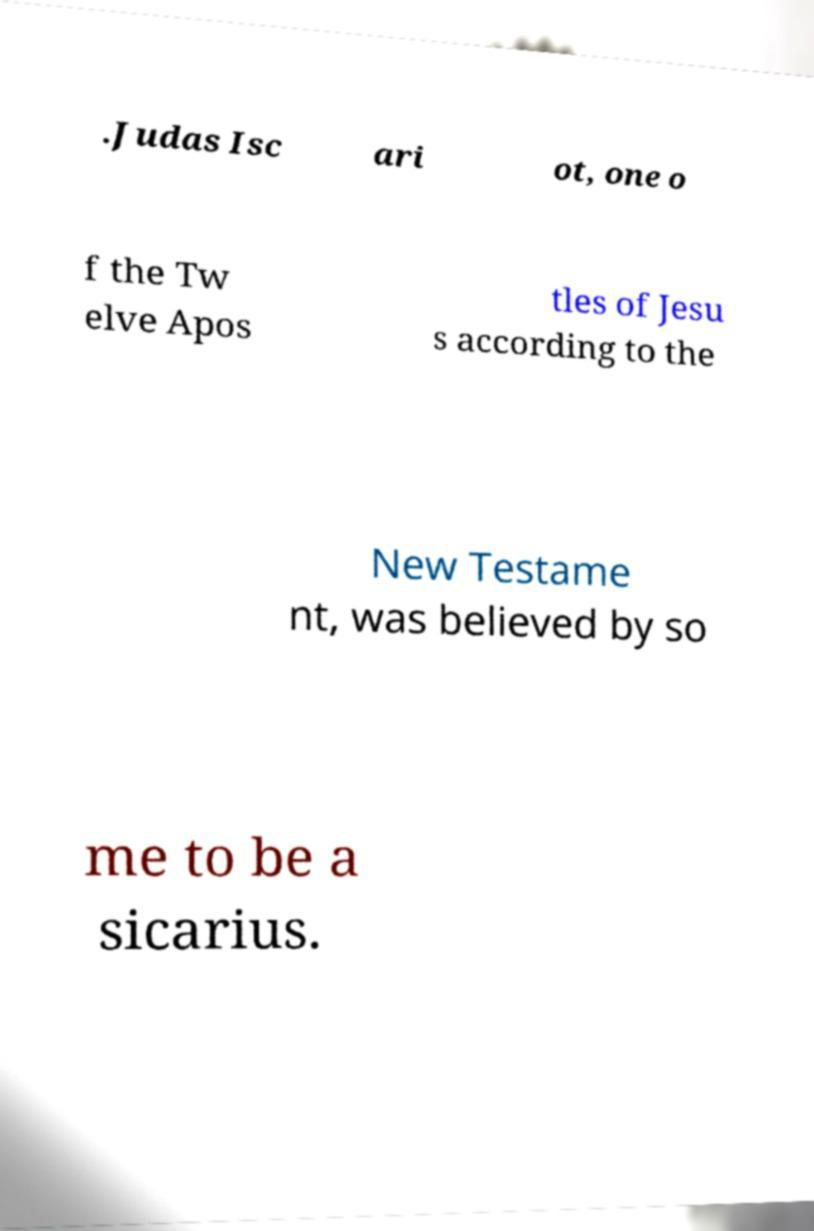Please read and relay the text visible in this image. What does it say? .Judas Isc ari ot, one o f the Tw elve Apos tles of Jesu s according to the New Testame nt, was believed by so me to be a sicarius. 